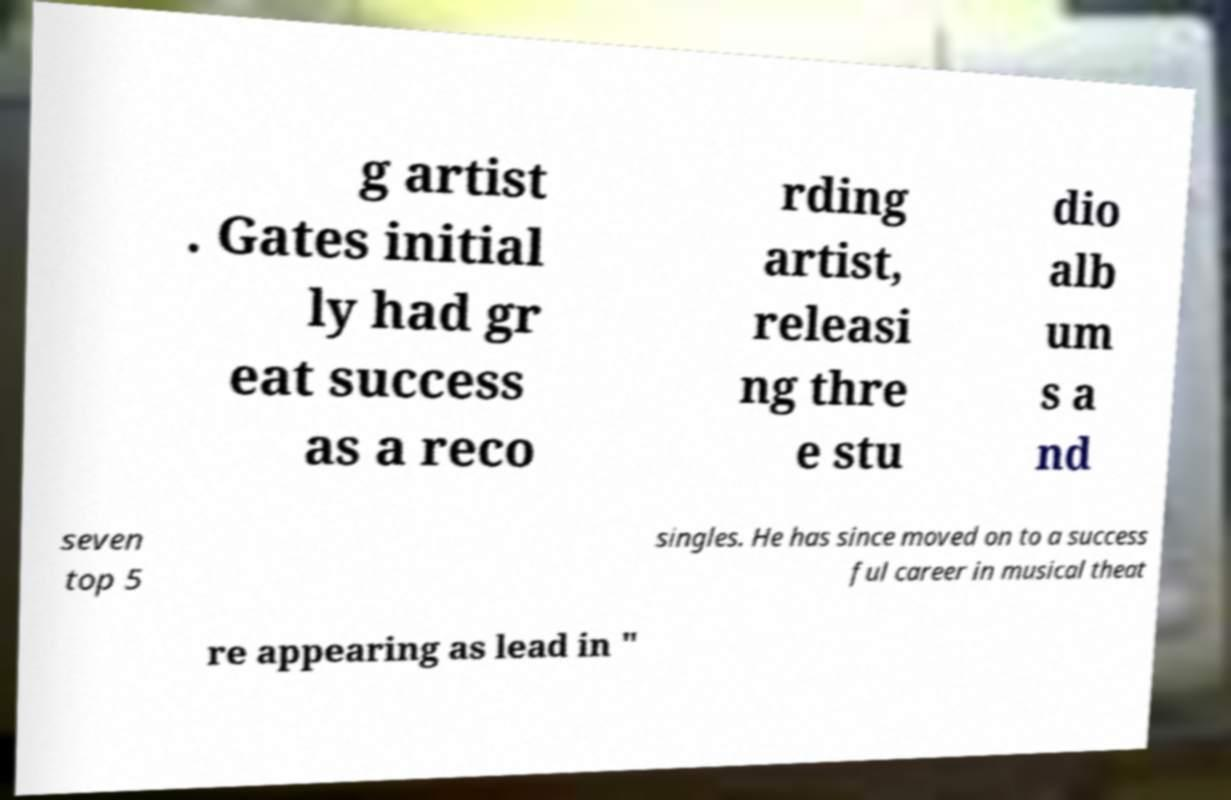Please identify and transcribe the text found in this image. g artist . Gates initial ly had gr eat success as a reco rding artist, releasi ng thre e stu dio alb um s a nd seven top 5 singles. He has since moved on to a success ful career in musical theat re appearing as lead in " 